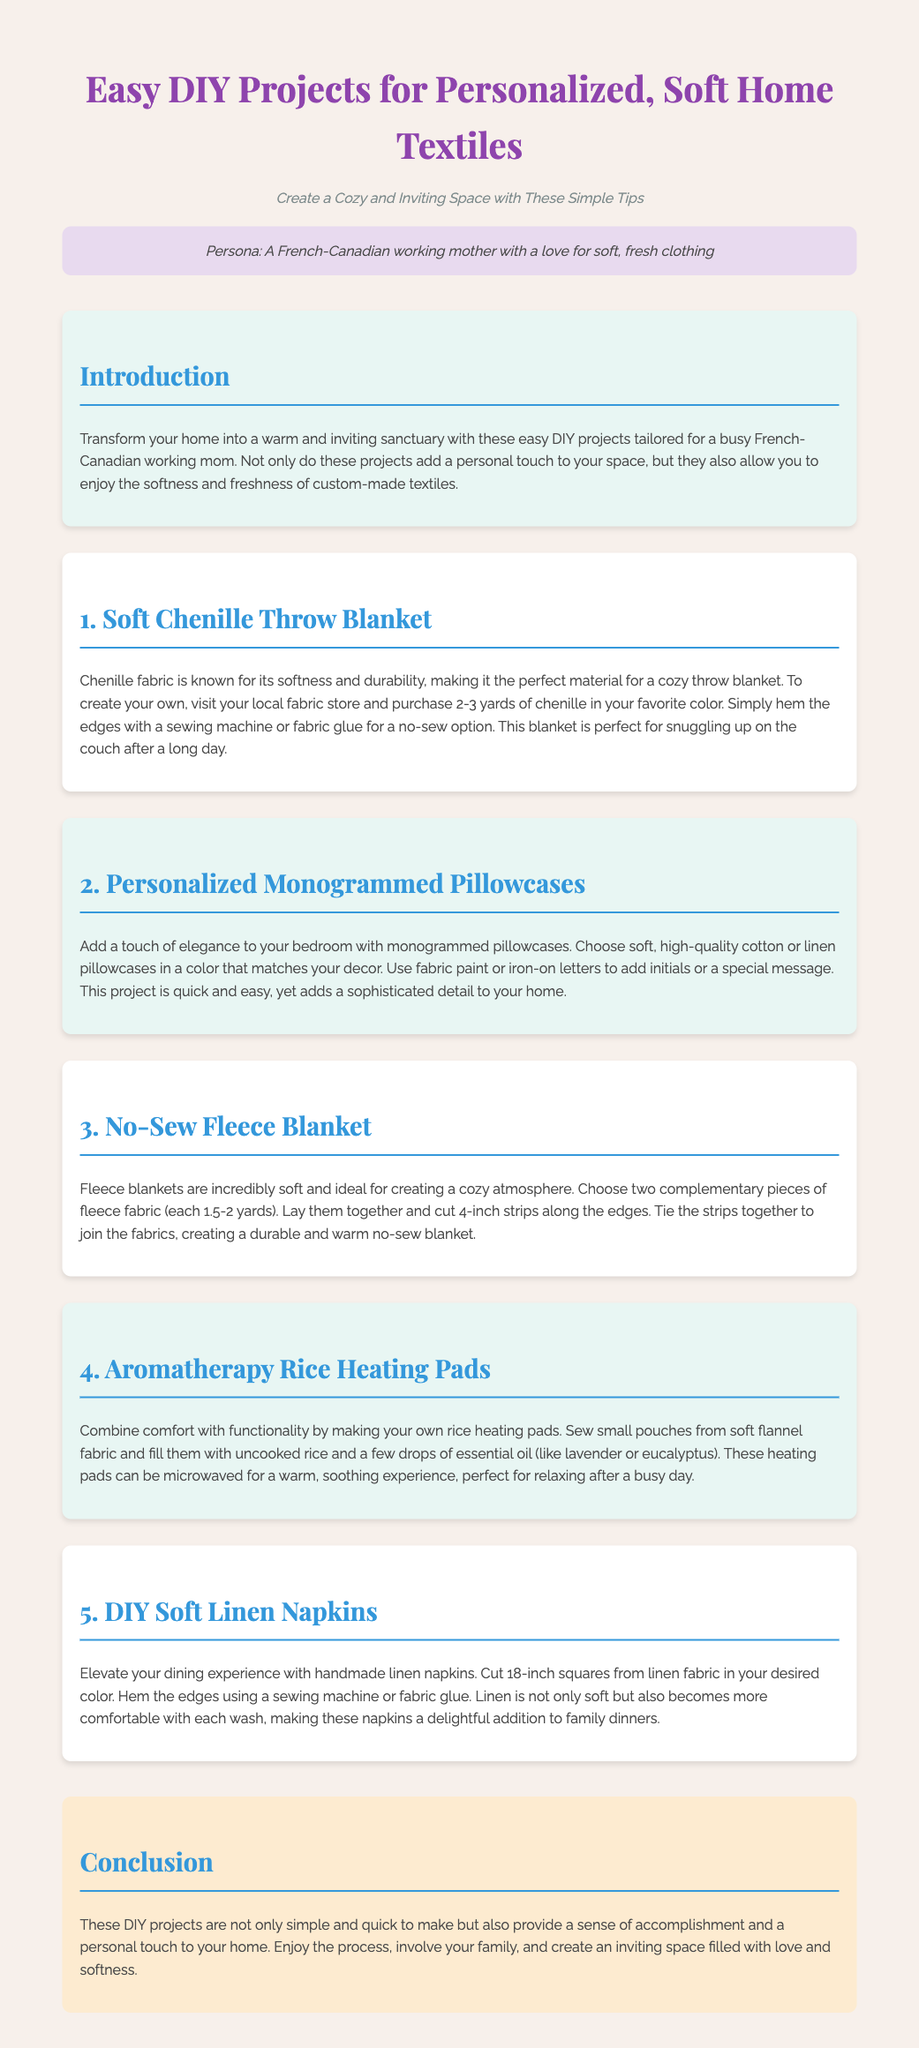What is the title of the document? The title is given in the header of the document, which is "Easy DIY Projects for Personalized, Soft Home Textiles."
Answer: Easy DIY Projects for Personalized, Soft Home Textiles Who are the intended readers of this document? The document states in the persona section that it is tailored for "A French-Canadian working mother."
Answer: A French-Canadian working mother How many DIY projects are listed in the document? The document enumerates five distinct DIY projects in the sections, indicating the number of projects clearly.
Answer: 5 What fabric is used for the Soft Chenille Throw Blanket? The first project description specifies that chenille fabric is used for making the throw blanket.
Answer: Chenille What is a unique feature of the personalized monogrammed pillowcases? The document notes that they can be customized with initials or a special message, adding a personal touch.
Answer: Monogrammed What can you fill the rice heating pads with? The description for the rice heating pads mentions that they are filled with uncooked rice and essential oils.
Answer: Rice and essential oil Which material is suggested for making the DIY Soft Linen Napkins? The project for napkins specifies using linen fabric, which is highlighted for its softness.
Answer: Linen What is the length of the squares cut for Soft Linen Napkins? The description states that the size of the squares is 18 inches for making the napkins.
Answer: 18 inches 